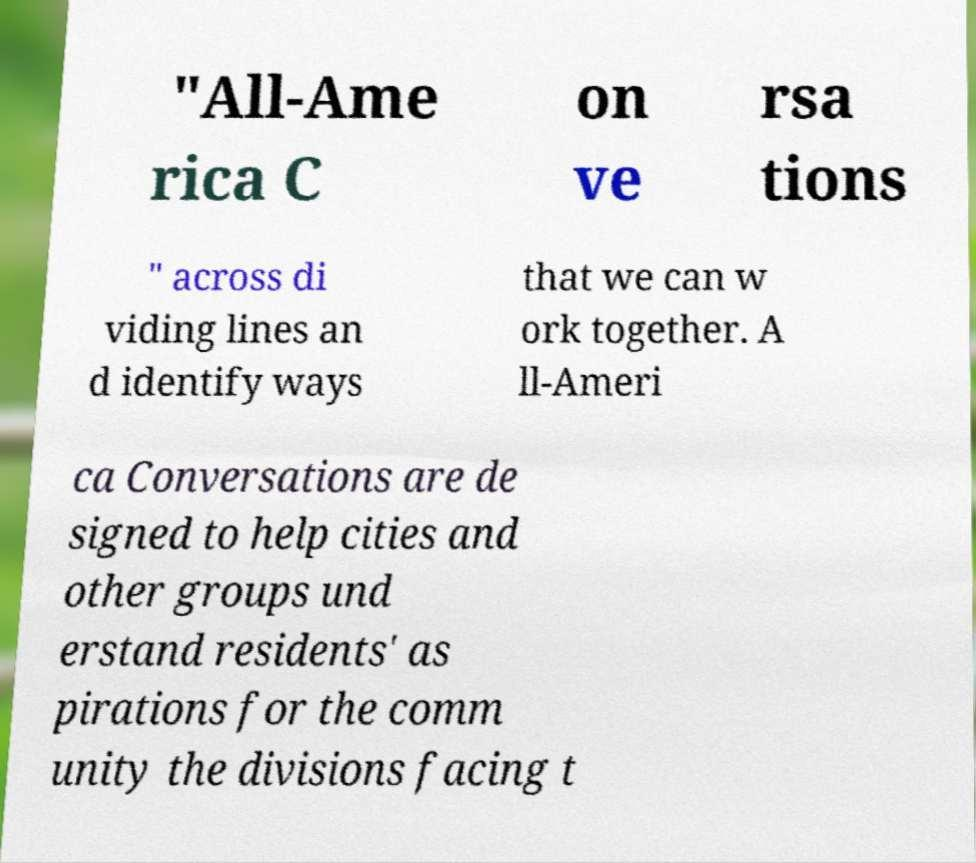Could you extract and type out the text from this image? "All-Ame rica C on ve rsa tions " across di viding lines an d identify ways that we can w ork together. A ll-Ameri ca Conversations are de signed to help cities and other groups und erstand residents' as pirations for the comm unity the divisions facing t 